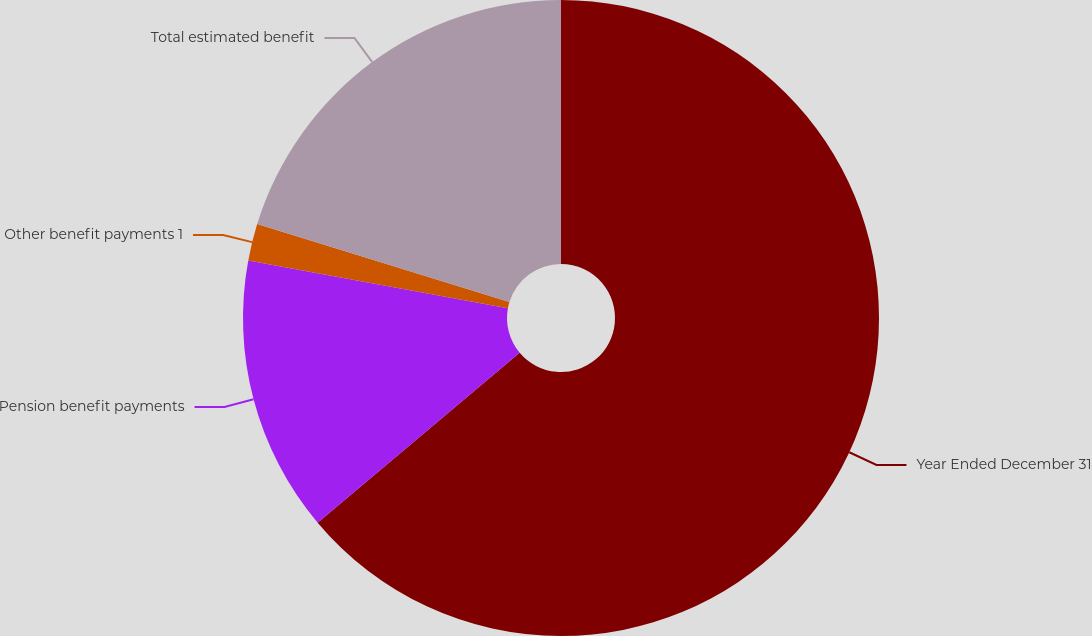Convert chart. <chart><loc_0><loc_0><loc_500><loc_500><pie_chart><fcel>Year Ended December 31<fcel>Pension benefit payments<fcel>Other benefit payments 1<fcel>Total estimated benefit<nl><fcel>63.87%<fcel>14.03%<fcel>1.87%<fcel>20.23%<nl></chart> 